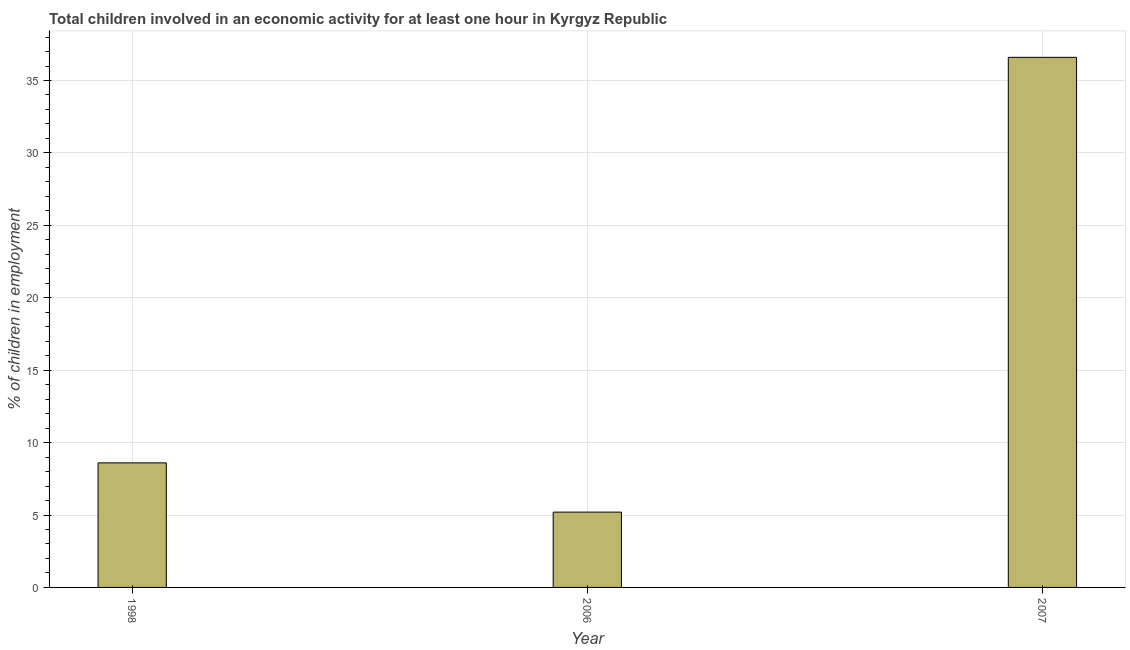Does the graph contain grids?
Provide a succinct answer. Yes. What is the title of the graph?
Ensure brevity in your answer.  Total children involved in an economic activity for at least one hour in Kyrgyz Republic. What is the label or title of the Y-axis?
Give a very brief answer. % of children in employment. What is the percentage of children in employment in 2006?
Provide a short and direct response. 5.2. Across all years, what is the maximum percentage of children in employment?
Offer a terse response. 36.6. Across all years, what is the minimum percentage of children in employment?
Ensure brevity in your answer.  5.2. What is the sum of the percentage of children in employment?
Your response must be concise. 50.4. What is the difference between the percentage of children in employment in 1998 and 2006?
Make the answer very short. 3.4. What is the median percentage of children in employment?
Provide a succinct answer. 8.6. What is the ratio of the percentage of children in employment in 1998 to that in 2007?
Make the answer very short. 0.23. What is the difference between the highest and the second highest percentage of children in employment?
Offer a terse response. 28. What is the difference between the highest and the lowest percentage of children in employment?
Give a very brief answer. 31.4. In how many years, is the percentage of children in employment greater than the average percentage of children in employment taken over all years?
Your answer should be compact. 1. Are all the bars in the graph horizontal?
Offer a very short reply. No. What is the difference between two consecutive major ticks on the Y-axis?
Offer a terse response. 5. Are the values on the major ticks of Y-axis written in scientific E-notation?
Offer a terse response. No. What is the % of children in employment in 2006?
Offer a terse response. 5.2. What is the % of children in employment in 2007?
Your answer should be compact. 36.6. What is the difference between the % of children in employment in 1998 and 2006?
Offer a terse response. 3.4. What is the difference between the % of children in employment in 1998 and 2007?
Give a very brief answer. -28. What is the difference between the % of children in employment in 2006 and 2007?
Your answer should be compact. -31.4. What is the ratio of the % of children in employment in 1998 to that in 2006?
Ensure brevity in your answer.  1.65. What is the ratio of the % of children in employment in 1998 to that in 2007?
Provide a short and direct response. 0.23. What is the ratio of the % of children in employment in 2006 to that in 2007?
Your answer should be very brief. 0.14. 